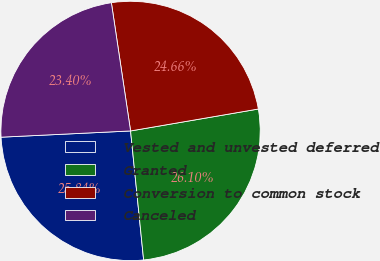<chart> <loc_0><loc_0><loc_500><loc_500><pie_chart><fcel>Vested and unvested deferred<fcel>Granted<fcel>Conversion to common stock<fcel>Canceled<nl><fcel>25.84%<fcel>26.1%<fcel>24.66%<fcel>23.4%<nl></chart> 